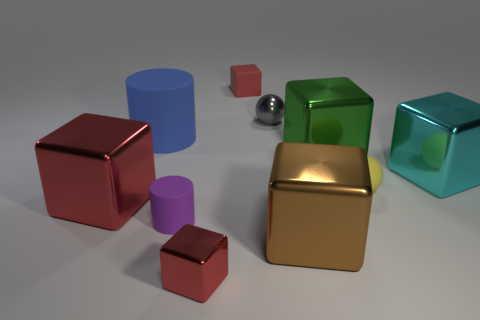How many red cubes must be subtracted to get 1 red cubes? 2 Subtract all big green metal blocks. How many blocks are left? 5 Subtract all blocks. How many objects are left? 4 Subtract 1 cylinders. How many cylinders are left? 1 Subtract all red cylinders. Subtract all gray balls. How many cylinders are left? 2 Subtract all purple balls. How many red blocks are left? 3 Subtract all big blue rubber cylinders. Subtract all metal balls. How many objects are left? 8 Add 7 large cyan objects. How many large cyan objects are left? 8 Add 3 large cyan cubes. How many large cyan cubes exist? 4 Subtract all red blocks. How many blocks are left? 3 